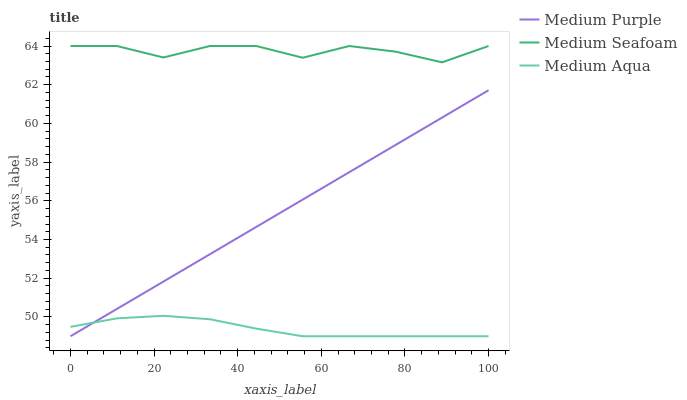Does Medium Aqua have the minimum area under the curve?
Answer yes or no. Yes. Does Medium Seafoam have the maximum area under the curve?
Answer yes or no. Yes. Does Medium Seafoam have the minimum area under the curve?
Answer yes or no. No. Does Medium Aqua have the maximum area under the curve?
Answer yes or no. No. Is Medium Purple the smoothest?
Answer yes or no. Yes. Is Medium Seafoam the roughest?
Answer yes or no. Yes. Is Medium Aqua the smoothest?
Answer yes or no. No. Is Medium Aqua the roughest?
Answer yes or no. No. Does Medium Purple have the lowest value?
Answer yes or no. Yes. Does Medium Seafoam have the lowest value?
Answer yes or no. No. Does Medium Seafoam have the highest value?
Answer yes or no. Yes. Does Medium Aqua have the highest value?
Answer yes or no. No. Is Medium Aqua less than Medium Seafoam?
Answer yes or no. Yes. Is Medium Seafoam greater than Medium Aqua?
Answer yes or no. Yes. Does Medium Purple intersect Medium Aqua?
Answer yes or no. Yes. Is Medium Purple less than Medium Aqua?
Answer yes or no. No. Is Medium Purple greater than Medium Aqua?
Answer yes or no. No. Does Medium Aqua intersect Medium Seafoam?
Answer yes or no. No. 